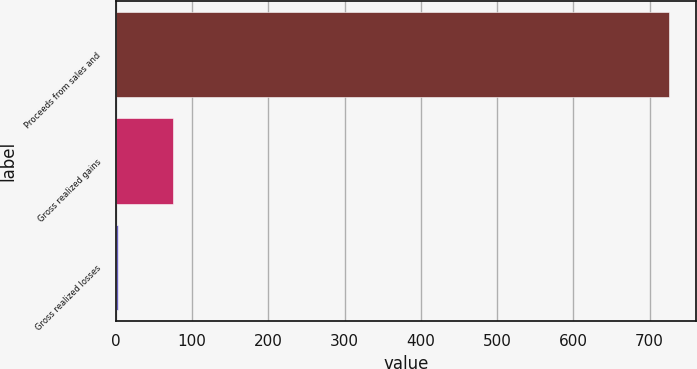Convert chart to OTSL. <chart><loc_0><loc_0><loc_500><loc_500><bar_chart><fcel>Proceeds from sales and<fcel>Gross realized gains<fcel>Gross realized losses<nl><fcel>725<fcel>74.57<fcel>2.3<nl></chart> 